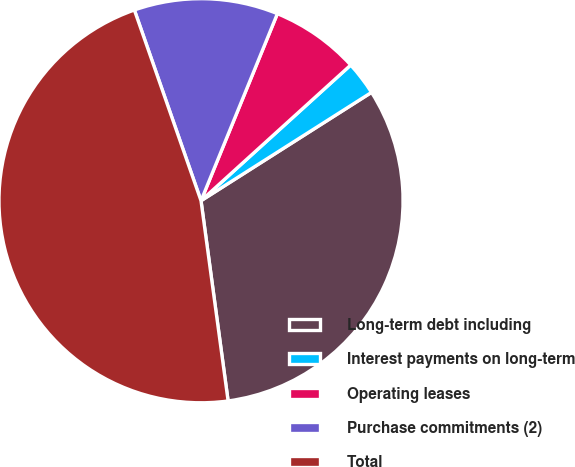Convert chart. <chart><loc_0><loc_0><loc_500><loc_500><pie_chart><fcel>Long-term debt including<fcel>Interest payments on long-term<fcel>Operating leases<fcel>Purchase commitments (2)<fcel>Total<nl><fcel>31.87%<fcel>2.71%<fcel>7.11%<fcel>11.52%<fcel>46.79%<nl></chart> 